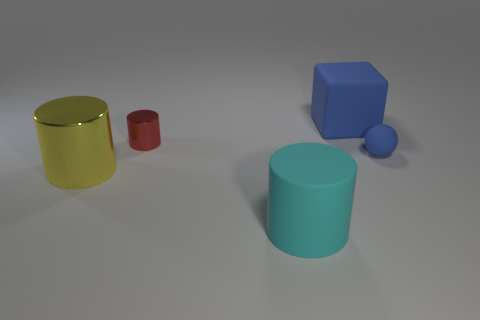What shape is the thing that is both on the left side of the rubber cylinder and behind the yellow cylinder?
Give a very brief answer. Cylinder. Is there a cyan object of the same size as the blue matte block?
Your answer should be very brief. Yes. What number of objects are either objects to the left of the sphere or rubber things?
Offer a terse response. 5. Is the big cyan thing made of the same material as the tiny object to the left of the big block?
Offer a terse response. No. What number of other things are there of the same shape as the big blue object?
Offer a very short reply. 0. How many things are either small things on the right side of the big blue matte block or large things that are on the left side of the large blue block?
Keep it short and to the point. 3. What number of other things are there of the same color as the cube?
Your answer should be very brief. 1. Is the number of rubber spheres that are in front of the blue matte cube less than the number of cylinders in front of the small red metal object?
Offer a terse response. Yes. How many small rubber balls are there?
Make the answer very short. 1. What is the material of the red object that is the same shape as the big yellow shiny thing?
Offer a terse response. Metal. 